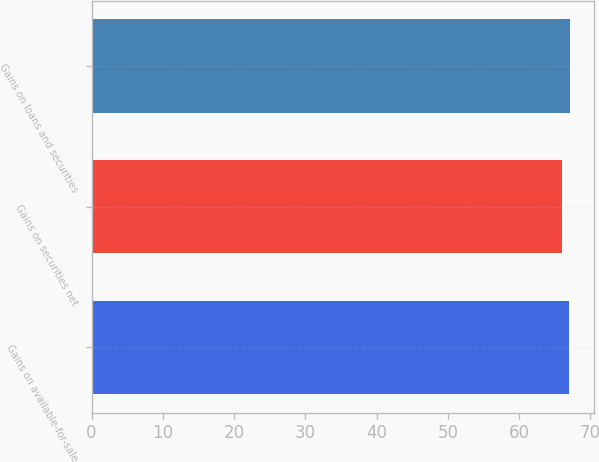Convert chart to OTSL. <chart><loc_0><loc_0><loc_500><loc_500><bar_chart><fcel>Gains on available-for-sale<fcel>Gains on securities net<fcel>Gains on loans and securities<nl><fcel>67<fcel>66<fcel>67.1<nl></chart> 